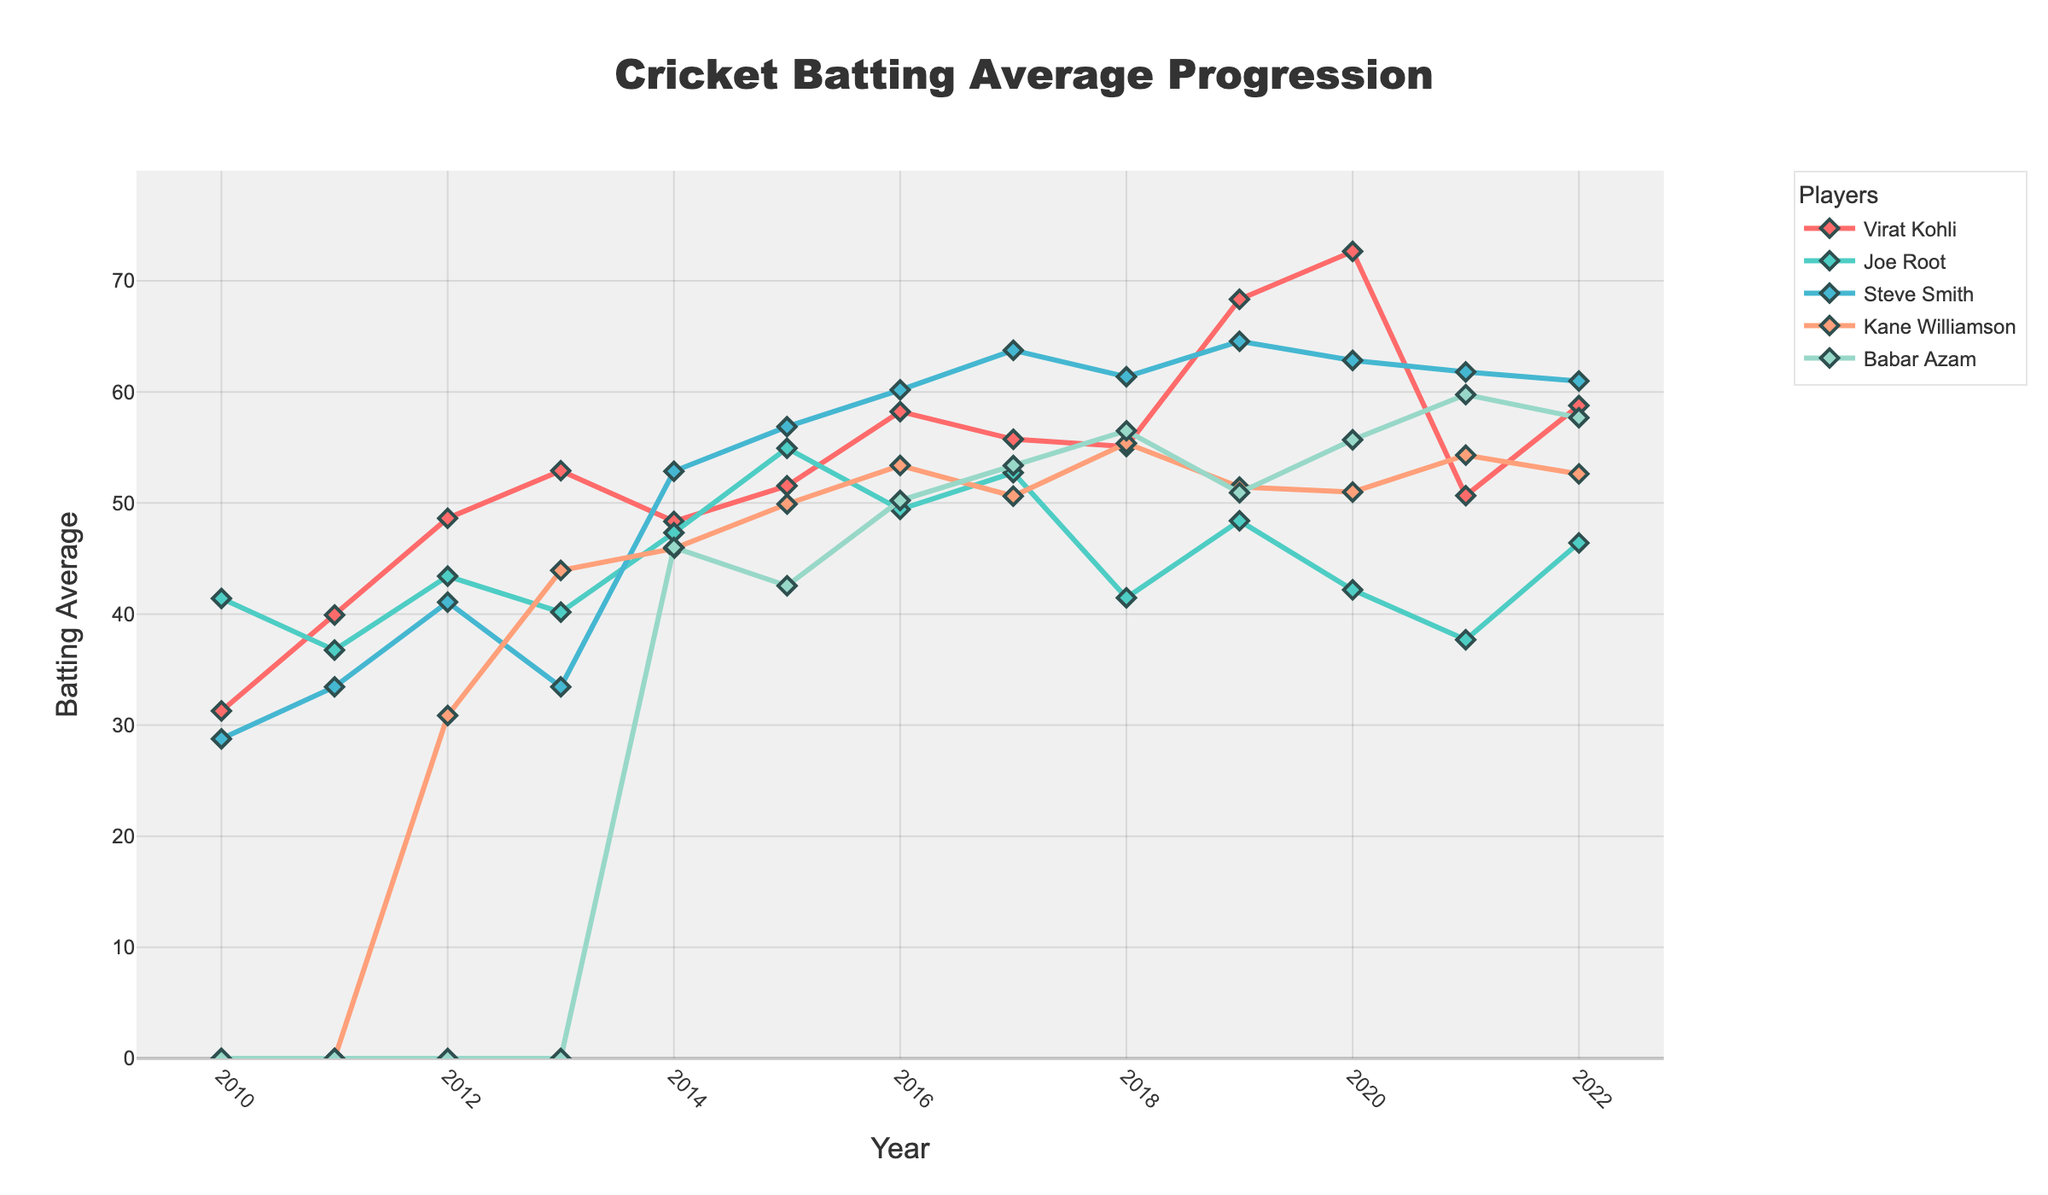Which player has the highest batting average in 2019? By looking at the 2019 data points on the line chart, you can see that Virat Kohli has the highest batting average, followed by Steve Smith.
Answer: Virat Kohli Who displayed the most improvement in batting average from 2012 to 2022? To find the player with the most improvement, calculate the difference between their batting averages in 2022 and 2012. The player with the largest positive difference is the one who improved the most. After comparing, Babar Azam shows the most improvement with his average going from 0 to 57.68.
Answer: Babar Azam Which player had a significant drop in their batting average between 2019 and 2020? Check the lines for any noticeable drops in height between 2019 and 2020. Joe Root's line significantly drops from 48.40 to 42.18, indicating a significant decrease in batting average.
Answer: Joe Root Between 2017 and 2018, whose batting average decreased the most? Compare the 2017 and 2018 values for each player and calculate the difference. Joe Root’s batting average dropped most, from 52.73 in 2017 to 41.47 in 2018, a decrease of 11.26 points.
Answer: Joe Root What is the average batting average of Steve Smith over the entire period? Sum up all the yearly averages for Steve Smith and then divide by the number of years he has data for. (Summing up Steve Smith's batting averages and dividing by 13 gives 52.05)
Answer: 52.05 In what year did Kane Williamson first appear in the data, and what was his average that year? Look for the first non-zero value in Kane Williamson’s line, which is in 2012, with an average of 30.87.
Answer: 2012, 30.87 Which player had the highest batting average in 2021? Check the data points for 2021. Babar Azam had the highest batting average in that year.
Answer: Babar Azam How many years did Virat Kohli and Steve Smith both have an average above 55? Look at the years where both Virat Kohli and Steve Smith’s averages are above 55. These years are 2016, 2017, and 2019.
Answer: 3 years What was Joe Root's lowest batting average, and in which year did it occur? Identify the lowest point on Joe Root’s line. His lowest batting average was 37.69 in 2021.
Answer: 37.69, 2021 Which player had the most consistent batting average over the entire period? Consistent performance would show as the least variation in the line chart. Kane Williamson has relatively fewer fluctuations compared to others over the years.
Answer: Kane Williamson 